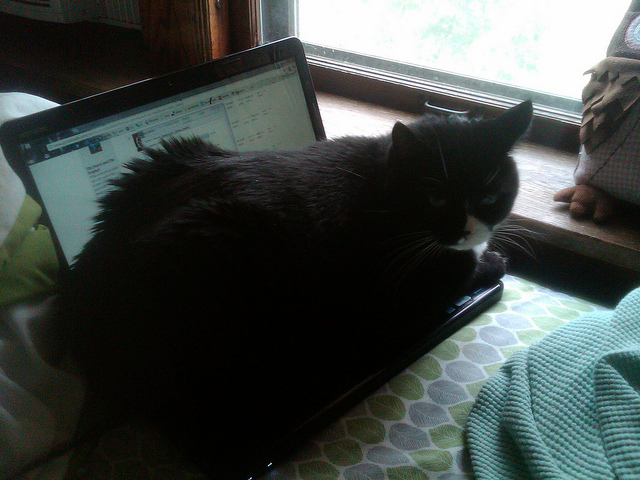What species of cats is looking outside the window? Based on the visual characteristics seen in the image, the cat appears to be a 'Tuxedo' cat, which isn't a species but a reference to its bicolor black and white coat pattern, commonly found in many domestic shorthair and longhair breeds. 